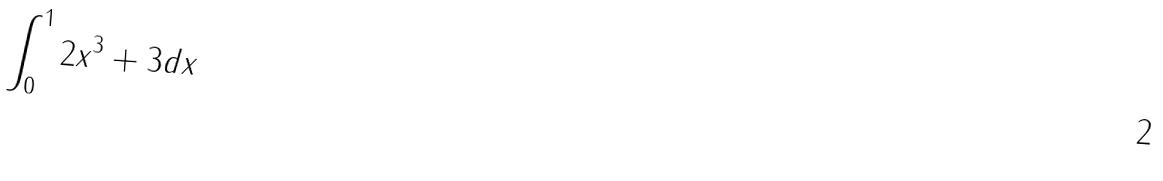<formula> <loc_0><loc_0><loc_500><loc_500>\int _ { 0 } ^ { 1 } 2 x ^ { 3 } + 3 d x</formula> 